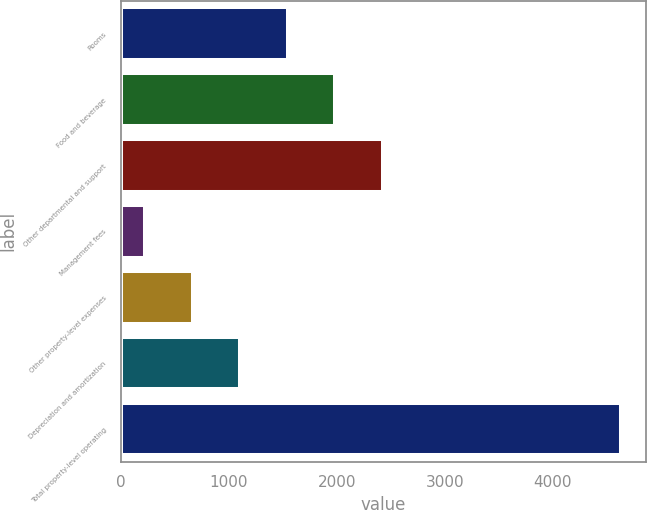Convert chart to OTSL. <chart><loc_0><loc_0><loc_500><loc_500><bar_chart><fcel>Rooms<fcel>Food and beverage<fcel>Other departmental and support<fcel>Management fees<fcel>Other property-level expenses<fcel>Depreciation and amortization<fcel>Total property-level operating<nl><fcel>1546.3<fcel>1986.4<fcel>2426.5<fcel>226<fcel>666.1<fcel>1106.2<fcel>4627<nl></chart> 